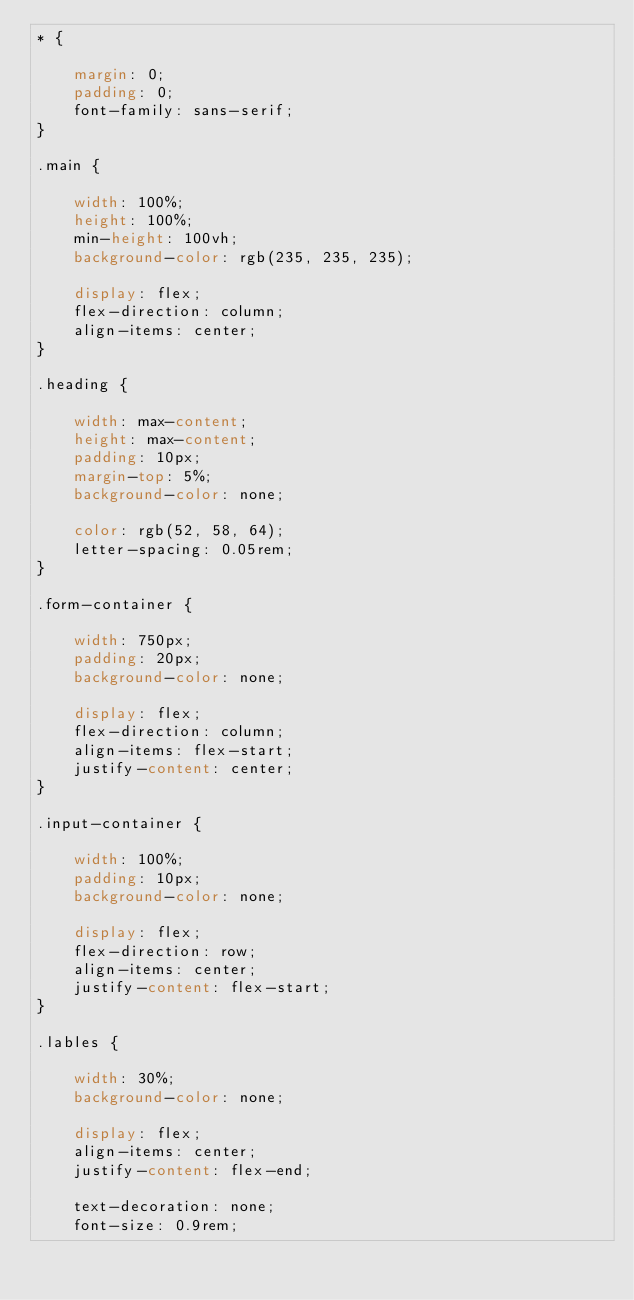<code> <loc_0><loc_0><loc_500><loc_500><_CSS_>* {

    margin: 0;
    padding: 0;
    font-family: sans-serif;
}

.main {

    width: 100%;
    height: 100%;
    min-height: 100vh;
    background-color: rgb(235, 235, 235);

    display: flex;
    flex-direction: column;
    align-items: center;
}

.heading {

    width: max-content;
    height: max-content;
    padding: 10px;
    margin-top: 5%;
    background-color: none;

    color: rgb(52, 58, 64);
    letter-spacing: 0.05rem;
}

.form-container {

    width: 750px;
    padding: 20px;
    background-color: none;

    display: flex;
    flex-direction: column;
    align-items: flex-start;
    justify-content: center;
}

.input-container {

    width: 100%;
    padding: 10px;
    background-color: none;

    display: flex;
    flex-direction: row;
    align-items: center;
    justify-content: flex-start;
}

.lables {

    width: 30%;
    background-color: none;

    display: flex;
    align-items: center;
    justify-content: flex-end;

    text-decoration: none;
    font-size: 0.9rem;</code> 